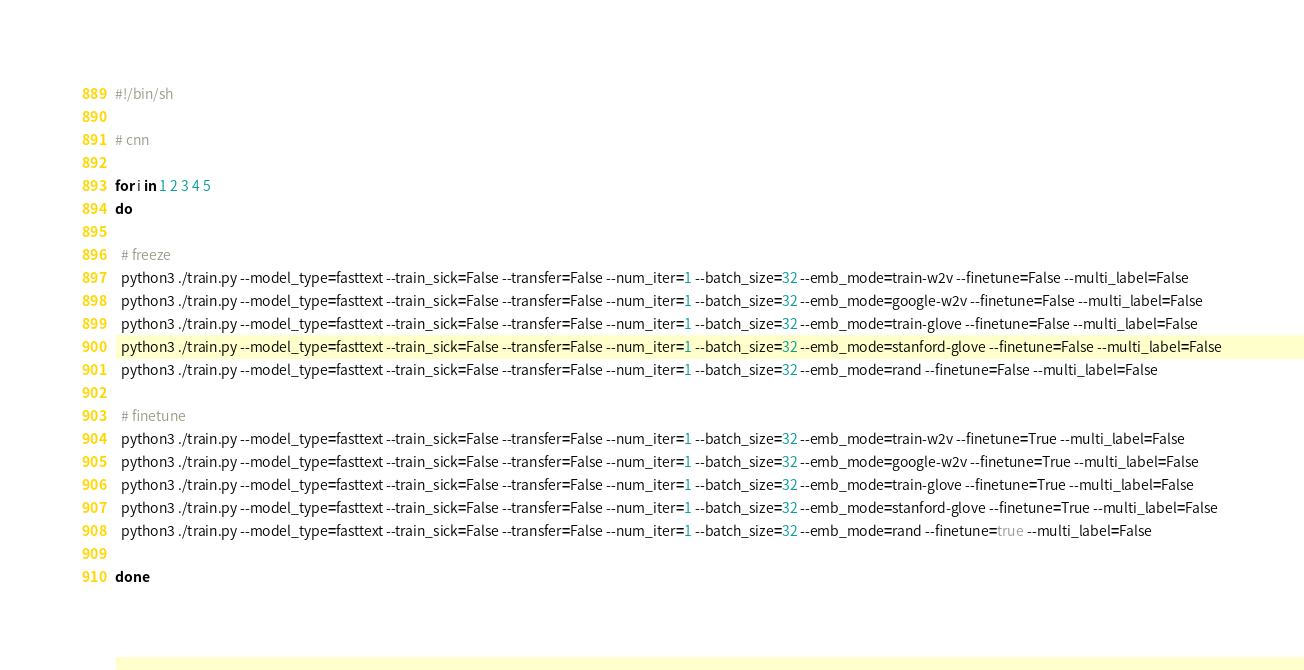<code> <loc_0><loc_0><loc_500><loc_500><_Bash_>#!/bin/sh

# cnn

for i in 1 2 3 4 5
do

  # freeze
  python3 ./train.py --model_type=fasttext --train_sick=False --transfer=False --num_iter=1 --batch_size=32 --emb_mode=train-w2v --finetune=False --multi_label=False
  python3 ./train.py --model_type=fasttext --train_sick=False --transfer=False --num_iter=1 --batch_size=32 --emb_mode=google-w2v --finetune=False --multi_label=False
  python3 ./train.py --model_type=fasttext --train_sick=False --transfer=False --num_iter=1 --batch_size=32 --emb_mode=train-glove --finetune=False --multi_label=False
  python3 ./train.py --model_type=fasttext --train_sick=False --transfer=False --num_iter=1 --batch_size=32 --emb_mode=stanford-glove --finetune=False --multi_label=False
  python3 ./train.py --model_type=fasttext --train_sick=False --transfer=False --num_iter=1 --batch_size=32 --emb_mode=rand --finetune=False --multi_label=False

  # finetune
  python3 ./train.py --model_type=fasttext --train_sick=False --transfer=False --num_iter=1 --batch_size=32 --emb_mode=train-w2v --finetune=True --multi_label=False
  python3 ./train.py --model_type=fasttext --train_sick=False --transfer=False --num_iter=1 --batch_size=32 --emb_mode=google-w2v --finetune=True --multi_label=False
  python3 ./train.py --model_type=fasttext --train_sick=False --transfer=False --num_iter=1 --batch_size=32 --emb_mode=train-glove --finetune=True --multi_label=False
  python3 ./train.py --model_type=fasttext --train_sick=False --transfer=False --num_iter=1 --batch_size=32 --emb_mode=stanford-glove --finetune=True --multi_label=False
  python3 ./train.py --model_type=fasttext --train_sick=False --transfer=False --num_iter=1 --batch_size=32 --emb_mode=rand --finetune=true --multi_label=False

done
</code> 